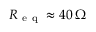<formula> <loc_0><loc_0><loc_500><loc_500>R _ { e q } \approx 4 0 \, \Omega</formula> 